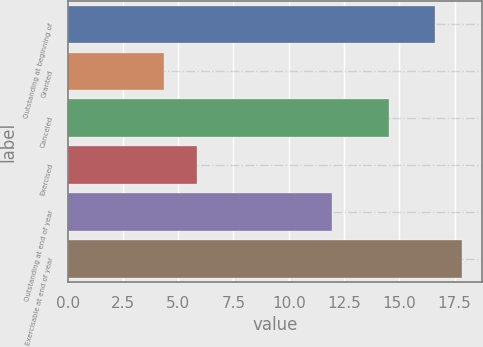<chart> <loc_0><loc_0><loc_500><loc_500><bar_chart><fcel>Outstanding at beginning of<fcel>Granted<fcel>Canceled<fcel>Exercised<fcel>Outstanding at end of year<fcel>Exercisable at end of year<nl><fcel>16.61<fcel>4.38<fcel>14.53<fcel>5.85<fcel>11.97<fcel>17.85<nl></chart> 